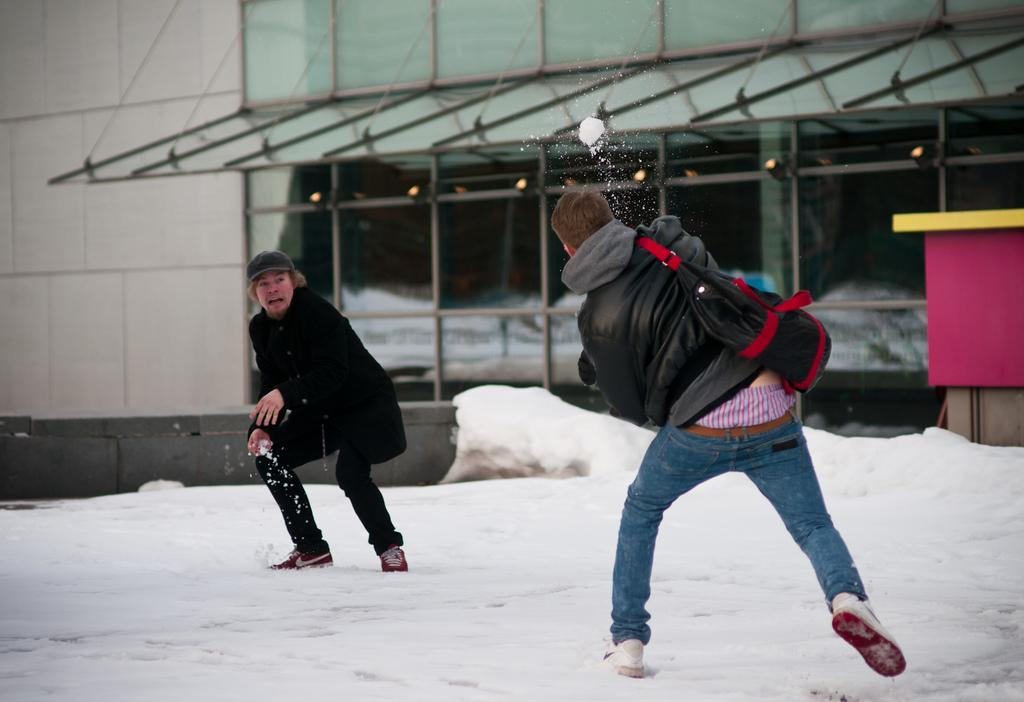What are the persons in the image doing? The persons in the image are standing and playing with snow. What can be seen in the background of the image? There is a building with windows and a box in the background. How many ants can be seen crawling on the persons playing with snow in the image? There are no ants visible in the image; it features persons playing with snow and a background with a building and a box. What nation is represented by the persons in the image? The provided facts do not give any information about the nationality of the persons in the image. 